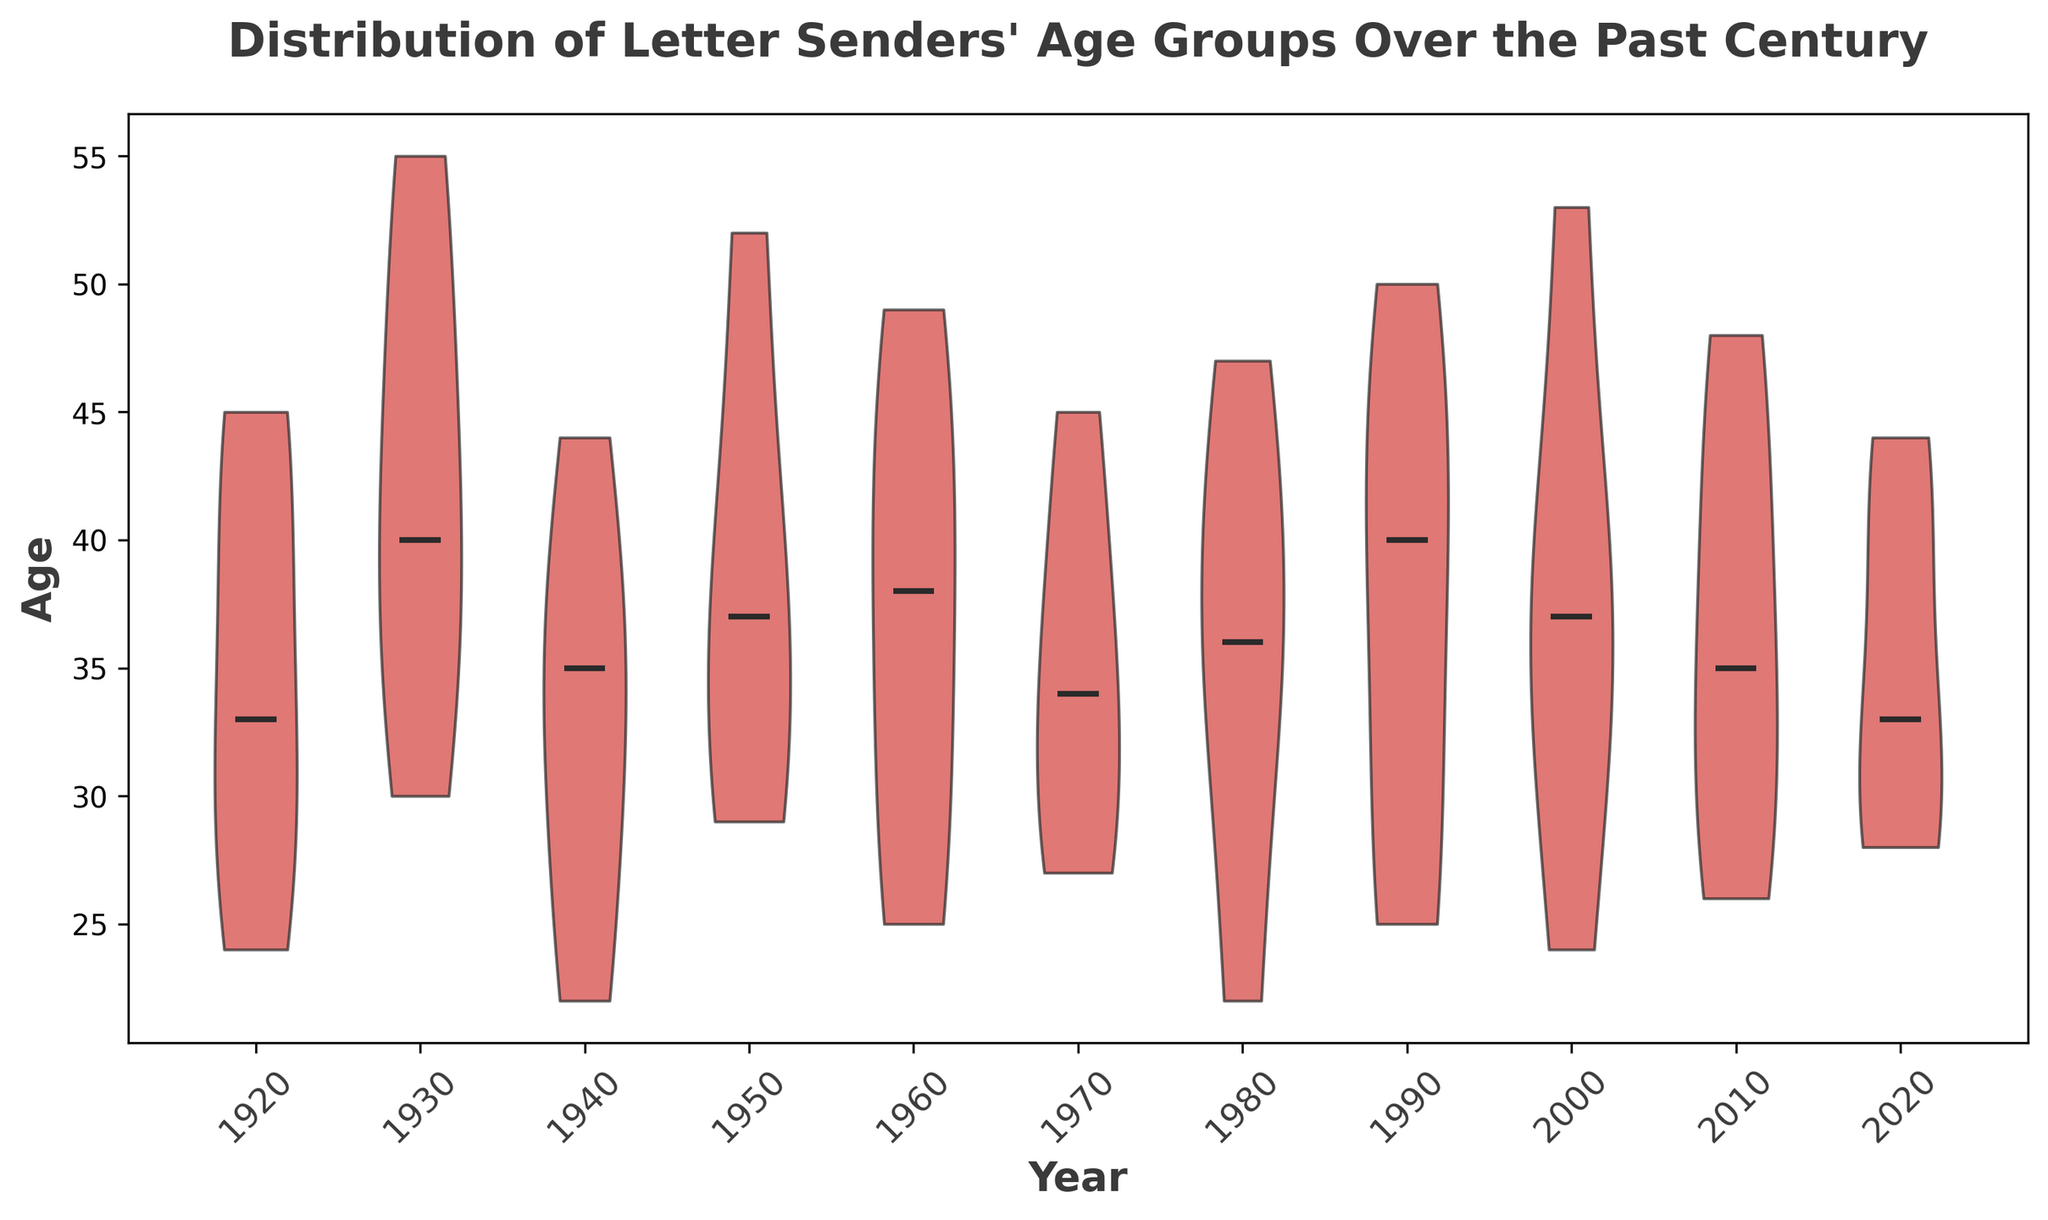What is the median age of letter senders in the year 2000? From the violin plot, identify the central line within the 2000 distribution as it indicates the median.
Answer: 37 In which decade do letter senders have the most diverse age range? Observe the spread of the violin plots. The decade with the widest range (from the top to the bottom of the violin) indicates the highest diversity.
Answer: 1930 Are letter senders in 1960 generally older or younger compared to those in 1920? Compare the positioning and spread of the 1960 and 1920 violin plots. If the 1960 plot is generally higher on the age axis, they are older.
Answer: Older Which year had the smallest interquartile range (IQR) for letter senders' ages? Identify the year where the central part of the violins (around the median) looks the thinnest, indicating a smaller IQR.
Answer: 1920 How does the age distribution in 2010 compare visually to the distribution in 1990? Compare the shape of the two violins: if 2010 is more spread out compared to 1990, it indicates a wider age range or distribution, and vice versa.
Answer: 2010 is more spread out What is the trend of the median age of letter senders from 1920 to 2020? Look at the central line of each violin plot sequentially from left to right to observe the upward or downward trend.
Answer: Increasing Do any years show an outlier significantly higher in age than the rest? Check within each violin for any small detached segment or marks far above the main body, indicating outliers.
Answer: No significant outliers Between 1930 and 1980, which period has a higher median age of letter senders? Compare the central lines of the violin plots for 1930 and 1980 directly.
Answer: 1930 Which year appears to have the youngest group of letter senders based on the data? Identify the lowest point of each violin plot and determine the one closest to the bottom of the age axis.
Answer: 1980 Is the variability of age more noticeable in the middle of the 20th century or towards the end of the century? Compare the spreads of the violin plots both in the middle (1940-1960) and end (1980-2000) of the 20th century to see where the variability is larger.
Answer: Middle of the 20th century 